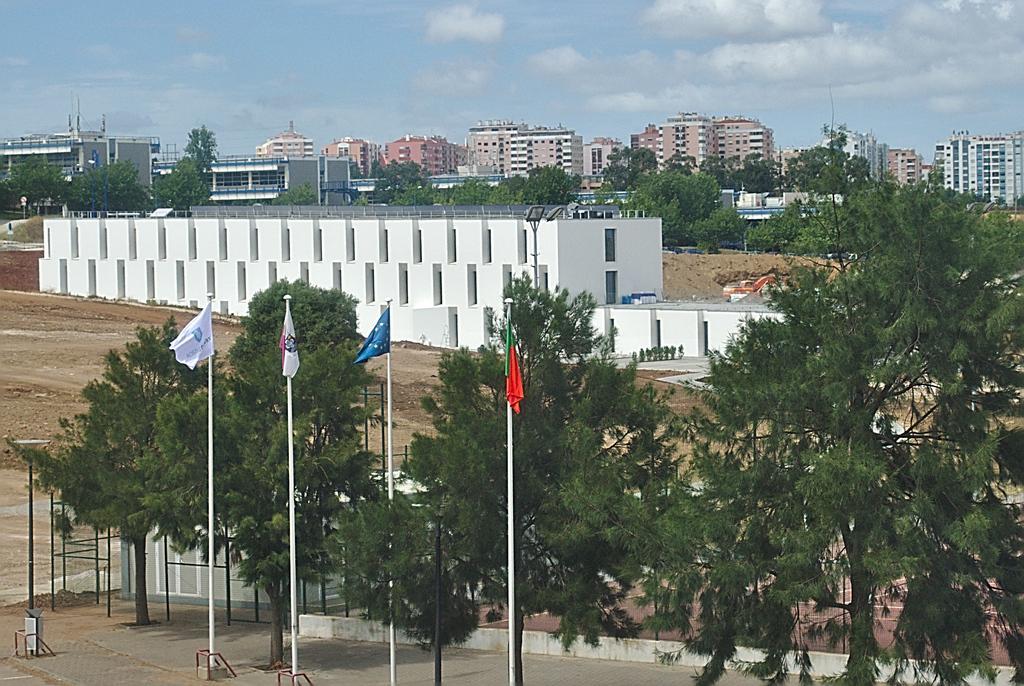Describe this image in one or two sentences. In the center of the image there are flags and trees. In the background there are buildings. At the top there is sky. 